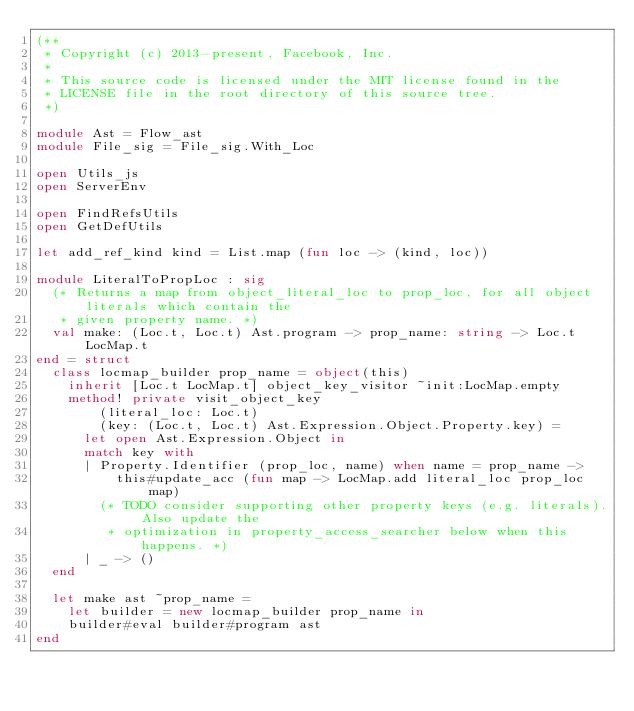Convert code to text. <code><loc_0><loc_0><loc_500><loc_500><_OCaml_>(**
 * Copyright (c) 2013-present, Facebook, Inc.
 *
 * This source code is licensed under the MIT license found in the
 * LICENSE file in the root directory of this source tree.
 *)

module Ast = Flow_ast
module File_sig = File_sig.With_Loc

open Utils_js
open ServerEnv

open FindRefsUtils
open GetDefUtils

let add_ref_kind kind = List.map (fun loc -> (kind, loc))

module LiteralToPropLoc : sig
  (* Returns a map from object_literal_loc to prop_loc, for all object literals which contain the
   * given property name. *)
  val make: (Loc.t, Loc.t) Ast.program -> prop_name: string -> Loc.t LocMap.t
end = struct
  class locmap_builder prop_name = object(this)
    inherit [Loc.t LocMap.t] object_key_visitor ~init:LocMap.empty
    method! private visit_object_key
        (literal_loc: Loc.t)
        (key: (Loc.t, Loc.t) Ast.Expression.Object.Property.key) =
      let open Ast.Expression.Object in
      match key with
      | Property.Identifier (prop_loc, name) when name = prop_name ->
          this#update_acc (fun map -> LocMap.add literal_loc prop_loc map)
        (* TODO consider supporting other property keys (e.g. literals). Also update the
         * optimization in property_access_searcher below when this happens. *)
      | _ -> ()
  end

  let make ast ~prop_name =
    let builder = new locmap_builder prop_name in
    builder#eval builder#program ast
end
</code> 